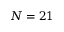<formula> <loc_0><loc_0><loc_500><loc_500>N = 2 1</formula> 